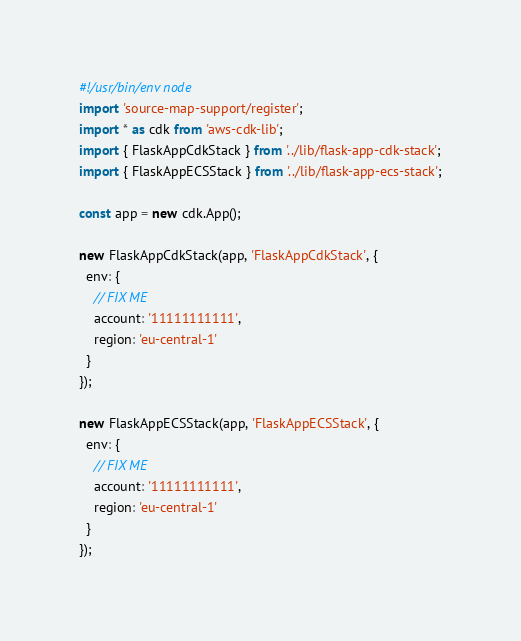Convert code to text. <code><loc_0><loc_0><loc_500><loc_500><_TypeScript_>#!/usr/bin/env node
import 'source-map-support/register';
import * as cdk from 'aws-cdk-lib';
import { FlaskAppCdkStack } from '../lib/flask-app-cdk-stack';
import { FlaskAppECSStack } from '../lib/flask-app-ecs-stack';

const app = new cdk.App();

new FlaskAppCdkStack(app, 'FlaskAppCdkStack', {
  env: {
    // FIX ME
    account: '11111111111',
    region: 'eu-central-1'
  }
});

new FlaskAppECSStack(app, 'FlaskAppECSStack', {
  env: {
    // FIX ME
    account: '11111111111',
    region: 'eu-central-1'
  }
});</code> 